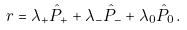Convert formula to latex. <formula><loc_0><loc_0><loc_500><loc_500>\ r = \lambda _ { + } \hat { P } _ { + } + \lambda _ { - } \hat { P } _ { - } + \lambda _ { 0 } \hat { P } _ { 0 } \, .</formula> 